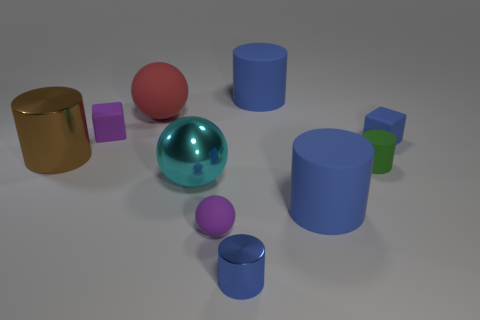There is a red thing; is its size the same as the cylinder that is behind the purple cube?
Your answer should be compact. Yes. What is the shape of the small blue object behind the tiny green rubber cylinder?
Keep it short and to the point. Cube. There is a purple block that is behind the tiny cube on the right side of the cyan sphere; are there any cylinders behind it?
Keep it short and to the point. Yes. There is a small purple thing that is the same shape as the small blue matte object; what material is it?
Your answer should be very brief. Rubber. Are there any other things that have the same material as the cyan ball?
Keep it short and to the point. Yes. How many cylinders are rubber objects or small blue objects?
Your answer should be very brief. 4. There is a cube that is right of the large red matte object; is its size the same as the blue matte thing that is in front of the small blue cube?
Your response must be concise. No. What is the material of the tiny cylinder behind the metal cylinder in front of the tiny green rubber cylinder?
Make the answer very short. Rubber. Are there fewer blue cylinders on the left side of the red thing than small red matte cubes?
Keep it short and to the point. No. There is a large brown thing that is the same material as the small blue cylinder; what shape is it?
Provide a short and direct response. Cylinder. 